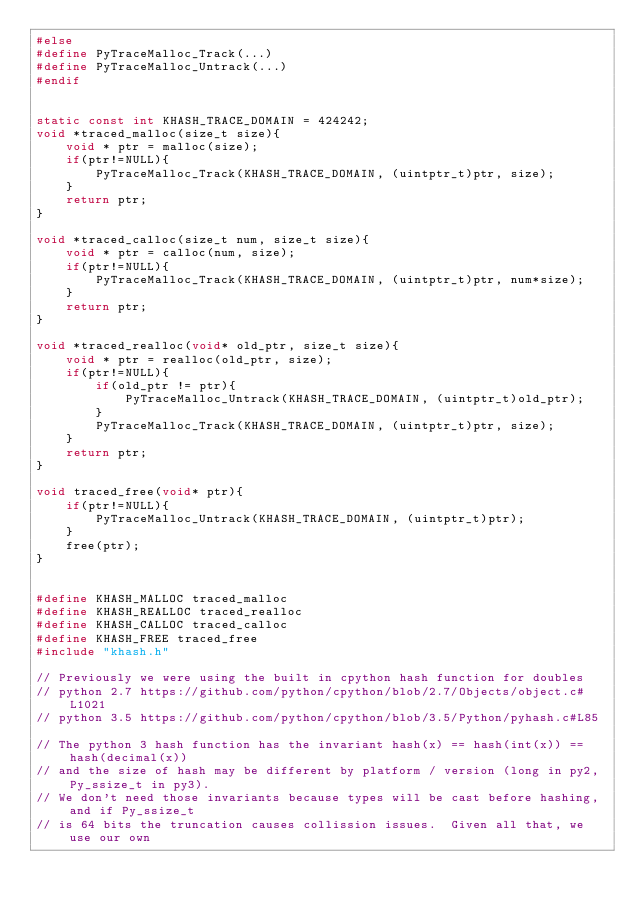Convert code to text. <code><loc_0><loc_0><loc_500><loc_500><_C_>#else
#define PyTraceMalloc_Track(...)
#define PyTraceMalloc_Untrack(...)
#endif


static const int KHASH_TRACE_DOMAIN = 424242;
void *traced_malloc(size_t size){
    void * ptr = malloc(size);
    if(ptr!=NULL){
        PyTraceMalloc_Track(KHASH_TRACE_DOMAIN, (uintptr_t)ptr, size);
    }
    return ptr;
}

void *traced_calloc(size_t num, size_t size){
    void * ptr = calloc(num, size);
    if(ptr!=NULL){
        PyTraceMalloc_Track(KHASH_TRACE_DOMAIN, (uintptr_t)ptr, num*size);
    }
    return ptr;
}

void *traced_realloc(void* old_ptr, size_t size){
    void * ptr = realloc(old_ptr, size);
    if(ptr!=NULL){
        if(old_ptr != ptr){
            PyTraceMalloc_Untrack(KHASH_TRACE_DOMAIN, (uintptr_t)old_ptr);
        }
        PyTraceMalloc_Track(KHASH_TRACE_DOMAIN, (uintptr_t)ptr, size);
    }
    return ptr;
}

void traced_free(void* ptr){
    if(ptr!=NULL){
        PyTraceMalloc_Untrack(KHASH_TRACE_DOMAIN, (uintptr_t)ptr);
    }
    free(ptr);
}


#define KHASH_MALLOC traced_malloc
#define KHASH_REALLOC traced_realloc
#define KHASH_CALLOC traced_calloc
#define KHASH_FREE traced_free
#include "khash.h"

// Previously we were using the built in cpython hash function for doubles
// python 2.7 https://github.com/python/cpython/blob/2.7/Objects/object.c#L1021
// python 3.5 https://github.com/python/cpython/blob/3.5/Python/pyhash.c#L85

// The python 3 hash function has the invariant hash(x) == hash(int(x)) == hash(decimal(x))
// and the size of hash may be different by platform / version (long in py2, Py_ssize_t in py3).
// We don't need those invariants because types will be cast before hashing, and if Py_ssize_t
// is 64 bits the truncation causes collission issues.  Given all that, we use our own</code> 